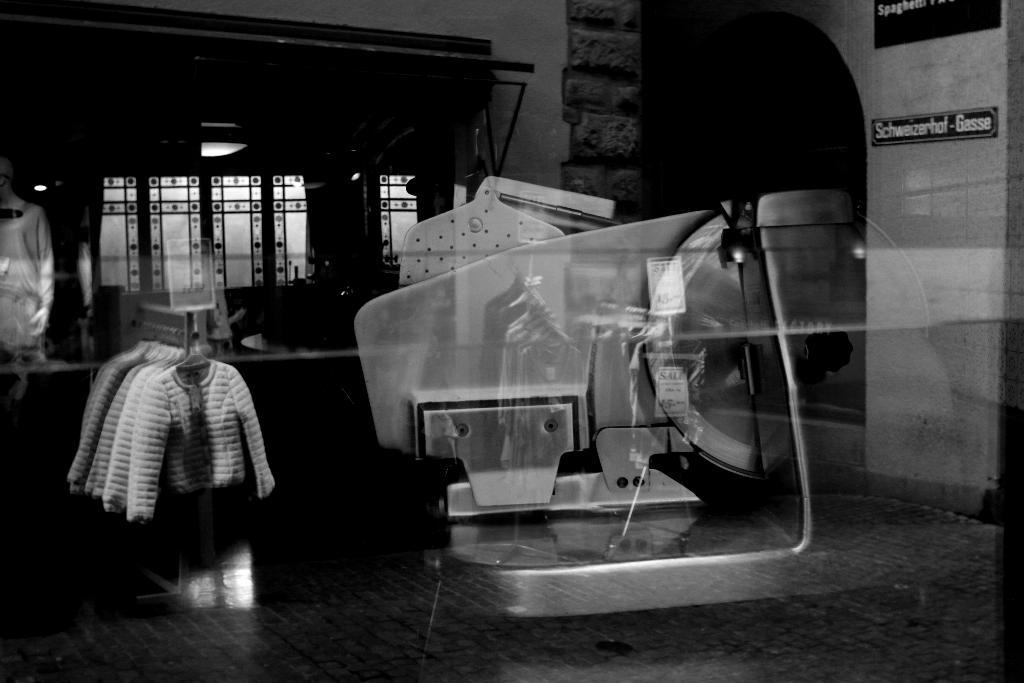What is the color scheme of the image? The image is black and white. Has the image been altered in any way? Yes, the image is edited. What can be seen reflecting in the image? There is a reflection of clothes and an object in the image. What is visible in the background of the image? There is a window in the background of the image. Can you see the steam coming from the moon in the image? There is no steam or moon present in the image; it is a black and white, edited image with reflections and a window in the background. 